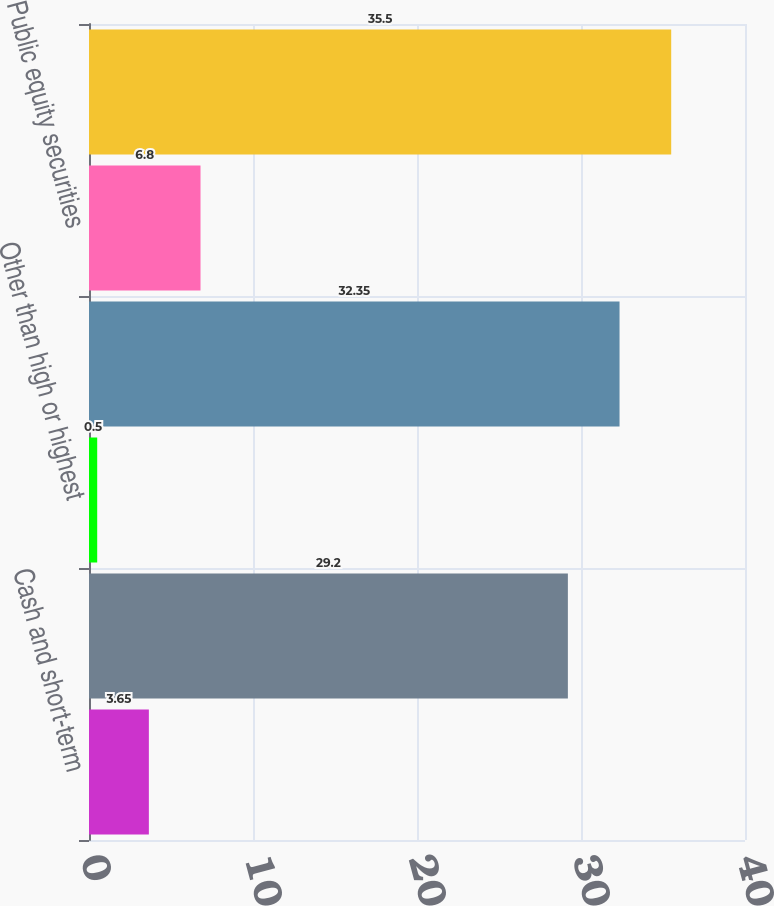<chart> <loc_0><loc_0><loc_500><loc_500><bar_chart><fcel>Cash and short-term<fcel>High or highest quality(3)<fcel>Other than high or highest<fcel>Subtotal<fcel>Public equity securities<fcel>Total<nl><fcel>3.65<fcel>29.2<fcel>0.5<fcel>32.35<fcel>6.8<fcel>35.5<nl></chart> 